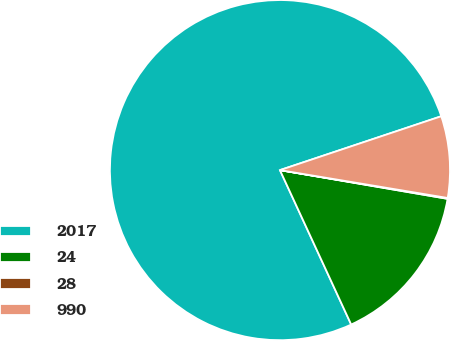Convert chart to OTSL. <chart><loc_0><loc_0><loc_500><loc_500><pie_chart><fcel>2017<fcel>24<fcel>28<fcel>990<nl><fcel>76.75%<fcel>15.42%<fcel>0.08%<fcel>7.75%<nl></chart> 